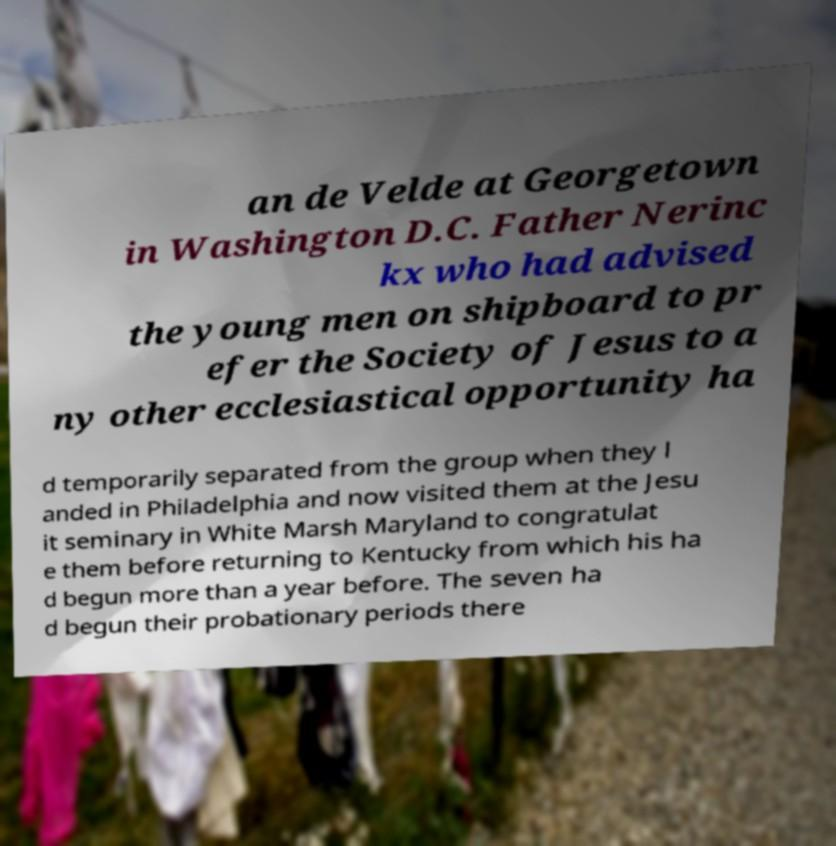Can you accurately transcribe the text from the provided image for me? an de Velde at Georgetown in Washington D.C. Father Nerinc kx who had advised the young men on shipboard to pr efer the Society of Jesus to a ny other ecclesiastical opportunity ha d temporarily separated from the group when they l anded in Philadelphia and now visited them at the Jesu it seminary in White Marsh Maryland to congratulat e them before returning to Kentucky from which his ha d begun more than a year before. The seven ha d begun their probationary periods there 